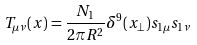Convert formula to latex. <formula><loc_0><loc_0><loc_500><loc_500>T _ { \mu \nu } ( x ) = { \frac { N _ { 1 } } { 2 \pi R ^ { 2 } } } \delta ^ { 9 } ( x _ { \perp } ) s _ { 1 \mu } s _ { 1 \nu }</formula> 